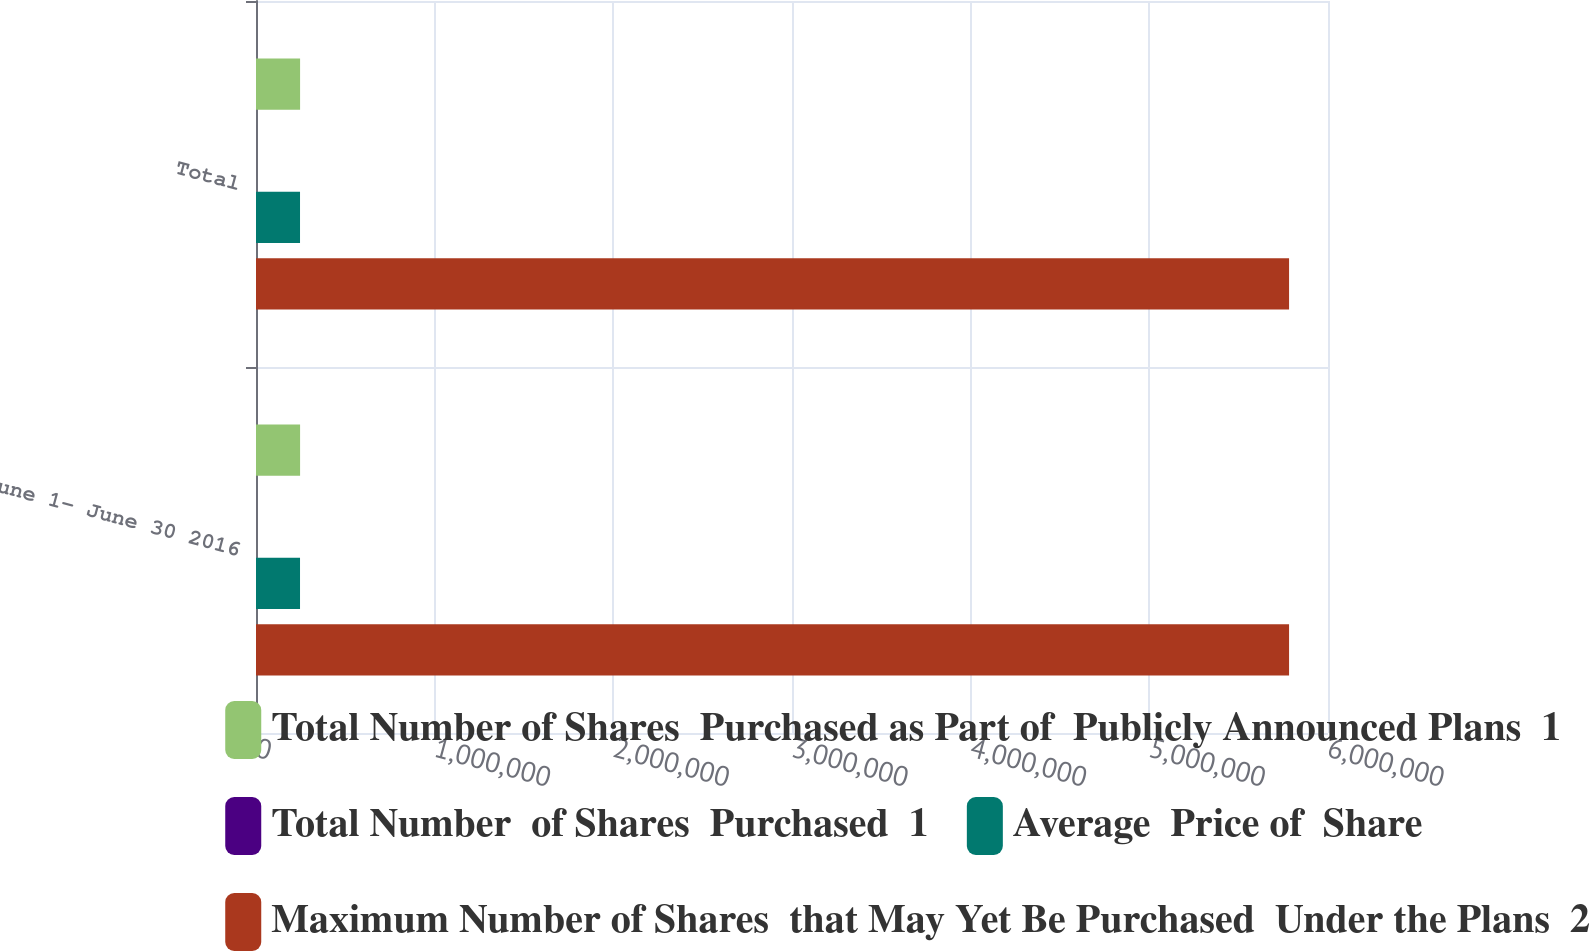Convert chart to OTSL. <chart><loc_0><loc_0><loc_500><loc_500><stacked_bar_chart><ecel><fcel>June 1- June 30 2016<fcel>Total<nl><fcel>Total Number of Shares  Purchased as Part of  Publicly Announced Plans  1<fcel>246746<fcel>246746<nl><fcel>Total Number  of Shares  Purchased  1<fcel>83.36<fcel>83.36<nl><fcel>Average  Price of  Share<fcel>246400<fcel>246400<nl><fcel>Maximum Number of Shares  that May Yet Be Purchased  Under the Plans  2<fcel>5.7821e+06<fcel>5.7821e+06<nl></chart> 